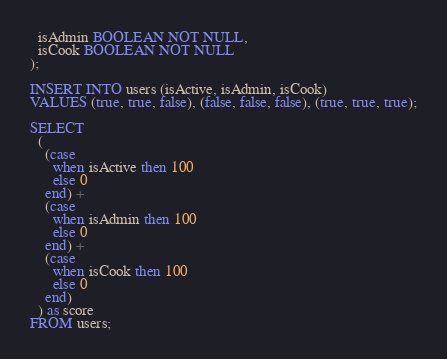Convert code to text. <code><loc_0><loc_0><loc_500><loc_500><_SQL_>  isAdmin BOOLEAN NOT NULL,
  isCook BOOLEAN NOT NULL
);

INSERT INTO users (isActive, isAdmin, isCook)
VALUES (true, true, false), (false, false, false), (true, true, true);

SELECT
  (
    (case 
      when isActive then 100
      else 0
    end) +
    (case 
      when isAdmin then 100
      else 0
    end) + 
    (case 
      when isCook then 100
      else 0
    end)
  ) as score
FROM users;</code> 